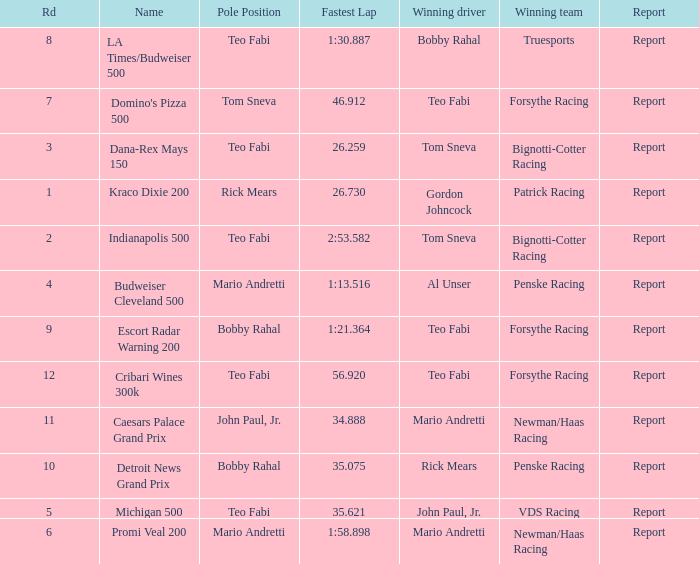What was the fastest lap time in the Escort Radar Warning 200? 1:21.364. 